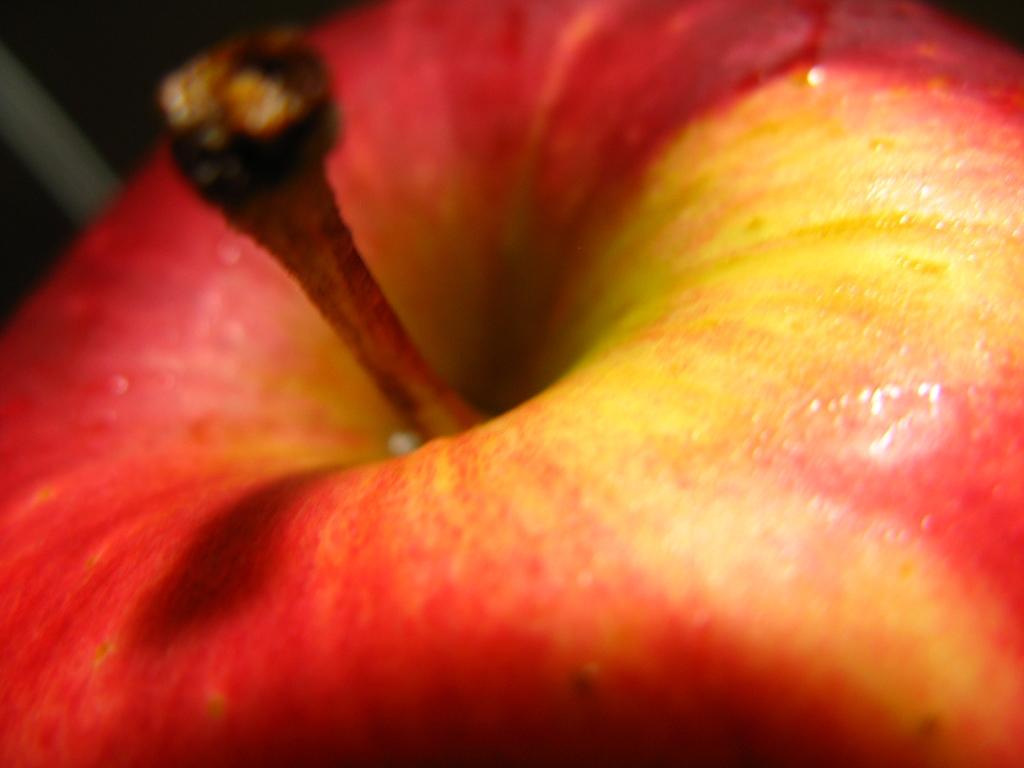What is the main subject of the picture? The main subject of the picture is an apple. Can you describe the color of the apple? The apple is red in color, with some parts being yellow. What is the grandfather doing in the picture? There is no grandfather present in the picture; it only features an apple. 